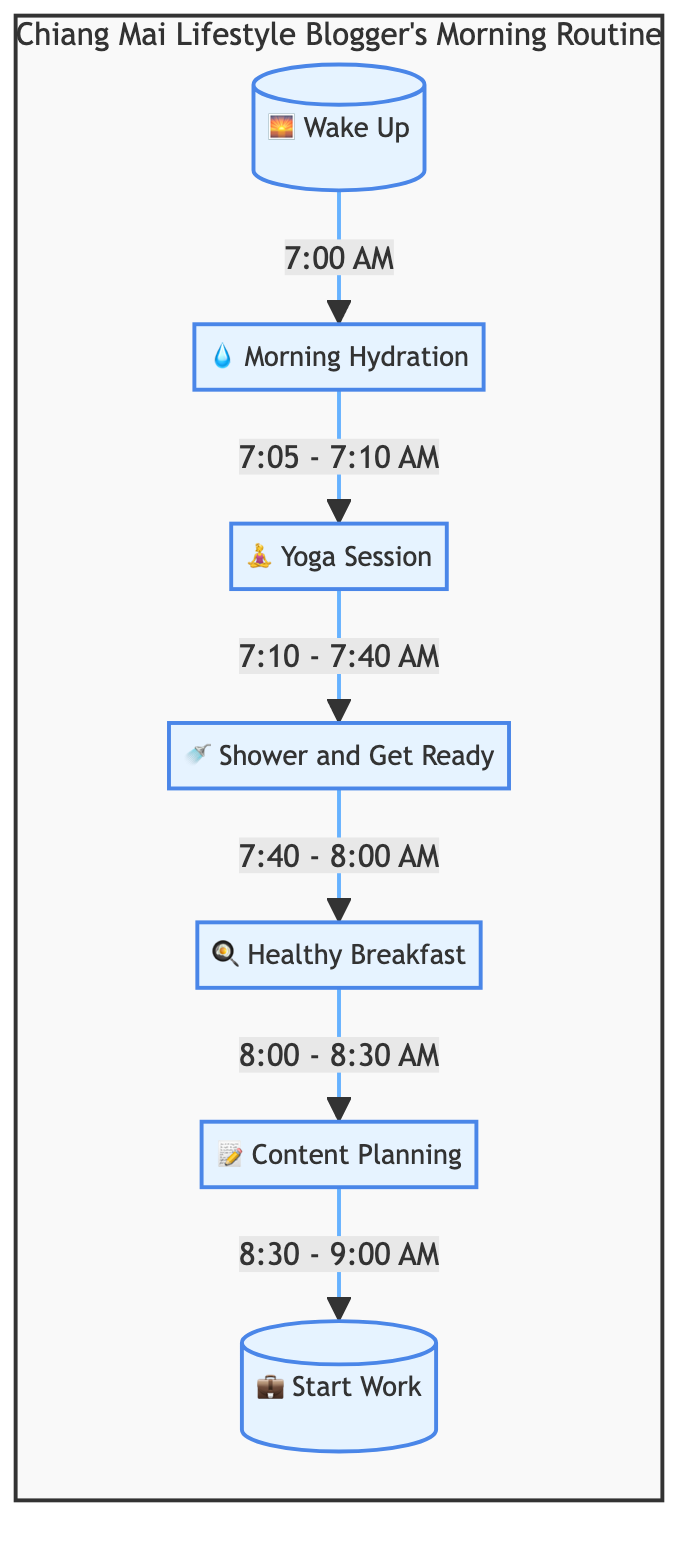What is the duration of the Yoga Session? The Yoga Session starts at 7:10 AM and ends at 7:40 AM. Thus, the duration is from 7:10 to 7:40, which is 30 minutes.
Answer: 30 minutes What activity follows Morning Hydration? According to the flow, after Morning Hydration, the next activity is the Yoga Session.
Answer: Yoga Session How many total nodes are there in the flow chart? The flow chart consists of seven activities from waking up to starting work, making a total of seven nodes.
Answer: 7 What time does the Healthy Breakfast end? The Healthy Breakfast begins at 8:00 AM and ends at 8:30 AM, thus it finishes at 8:30 AM.
Answer: 8:30 AM What is the first activity in the morning routine? The first activity listed is Wake Up, which starts the routine.
Answer: Wake Up What is the time allocated for Content Planning? The flow indicates that Content Planning occurs from 8:30 AM to 9:00 AM, giving it a duration of 30 minutes.
Answer: 30 minutes How does the flow chart define the relationship between the Yoga Session and Shower and Get Ready? The flow indicates progression from Yoga Session to Shower and Get Ready, showing a directional flow from one activity to the next.
Answer: Progression What is the last activity before starting work? The last activity before starting work is Content Planning, occurring just before the work starts at 9:00 AM.
Answer: Content Planning What time does the morning routine conclude? According to the flow, the morning routine concludes with the Start Work activity, which begins at 9:00 AM.
Answer: 9:00 AM 